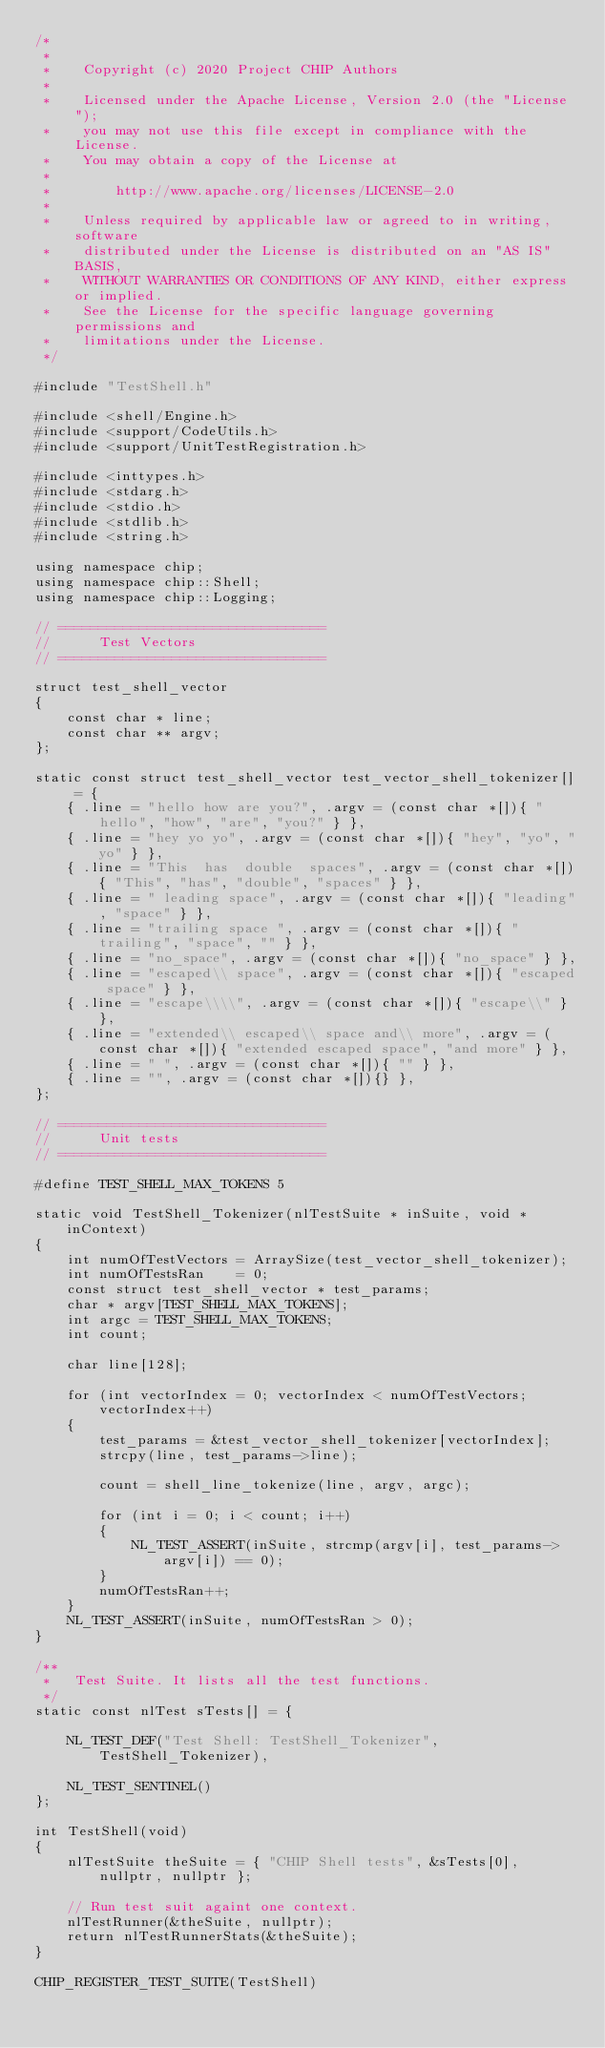Convert code to text. <code><loc_0><loc_0><loc_500><loc_500><_C++_>/*
 *
 *    Copyright (c) 2020 Project CHIP Authors
 *
 *    Licensed under the Apache License, Version 2.0 (the "License");
 *    you may not use this file except in compliance with the License.
 *    You may obtain a copy of the License at
 *
 *        http://www.apache.org/licenses/LICENSE-2.0
 *
 *    Unless required by applicable law or agreed to in writing, software
 *    distributed under the License is distributed on an "AS IS" BASIS,
 *    WITHOUT WARRANTIES OR CONDITIONS OF ANY KIND, either express or implied.
 *    See the License for the specific language governing permissions and
 *    limitations under the License.
 */

#include "TestShell.h"

#include <shell/Engine.h>
#include <support/CodeUtils.h>
#include <support/UnitTestRegistration.h>

#include <inttypes.h>
#include <stdarg.h>
#include <stdio.h>
#include <stdlib.h>
#include <string.h>

using namespace chip;
using namespace chip::Shell;
using namespace chip::Logging;

// =================================
//      Test Vectors
// =================================

struct test_shell_vector
{
    const char * line;
    const char ** argv;
};

static const struct test_shell_vector test_vector_shell_tokenizer[] = {
    { .line = "hello how are you?", .argv = (const char *[]){ "hello", "how", "are", "you?" } },
    { .line = "hey yo yo", .argv = (const char *[]){ "hey", "yo", "yo" } },
    { .line = "This  has  double  spaces", .argv = (const char *[]){ "This", "has", "double", "spaces" } },
    { .line = " leading space", .argv = (const char *[]){ "leading", "space" } },
    { .line = "trailing space ", .argv = (const char *[]){ "trailing", "space", "" } },
    { .line = "no_space", .argv = (const char *[]){ "no_space" } },
    { .line = "escaped\\ space", .argv = (const char *[]){ "escaped space" } },
    { .line = "escape\\\\", .argv = (const char *[]){ "escape\\" } },
    { .line = "extended\\ escaped\\ space and\\ more", .argv = (const char *[]){ "extended escaped space", "and more" } },
    { .line = " ", .argv = (const char *[]){ "" } },
    { .line = "", .argv = (const char *[]){} },
};

// =================================
//      Unit tests
// =================================

#define TEST_SHELL_MAX_TOKENS 5

static void TestShell_Tokenizer(nlTestSuite * inSuite, void * inContext)
{
    int numOfTestVectors = ArraySize(test_vector_shell_tokenizer);
    int numOfTestsRan    = 0;
    const struct test_shell_vector * test_params;
    char * argv[TEST_SHELL_MAX_TOKENS];
    int argc = TEST_SHELL_MAX_TOKENS;
    int count;

    char line[128];

    for (int vectorIndex = 0; vectorIndex < numOfTestVectors; vectorIndex++)
    {
        test_params = &test_vector_shell_tokenizer[vectorIndex];
        strcpy(line, test_params->line);

        count = shell_line_tokenize(line, argv, argc);

        for (int i = 0; i < count; i++)
        {
            NL_TEST_ASSERT(inSuite, strcmp(argv[i], test_params->argv[i]) == 0);
        }
        numOfTestsRan++;
    }
    NL_TEST_ASSERT(inSuite, numOfTestsRan > 0);
}

/**
 *   Test Suite. It lists all the test functions.
 */
static const nlTest sTests[] = {

    NL_TEST_DEF("Test Shell: TestShell_Tokenizer", TestShell_Tokenizer),

    NL_TEST_SENTINEL()
};

int TestShell(void)
{
    nlTestSuite theSuite = { "CHIP Shell tests", &sTests[0], nullptr, nullptr };

    // Run test suit againt one context.
    nlTestRunner(&theSuite, nullptr);
    return nlTestRunnerStats(&theSuite);
}

CHIP_REGISTER_TEST_SUITE(TestShell)
</code> 